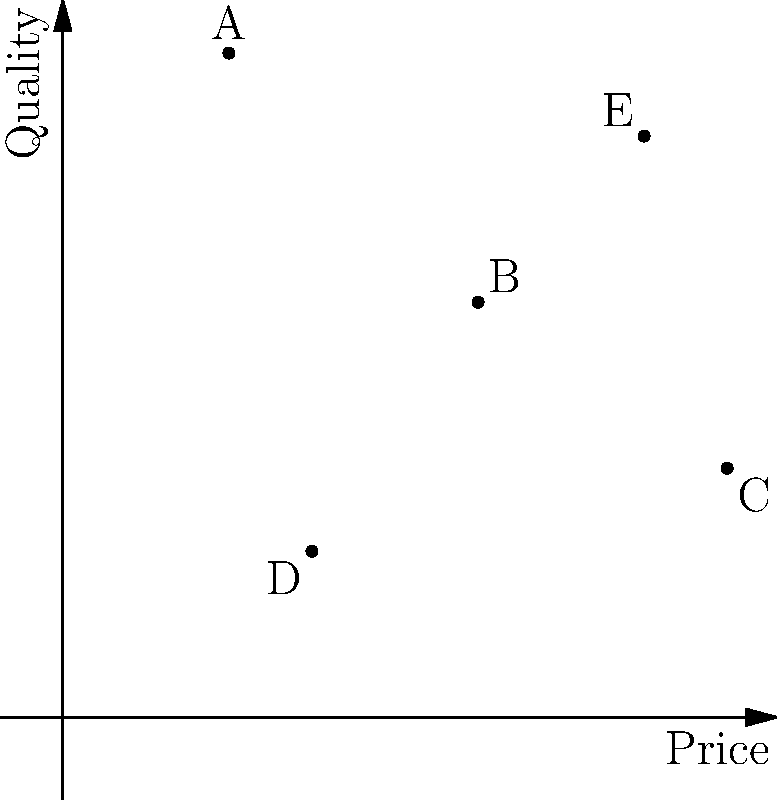Based on the perceptual map showing competitor positioning in terms of price and quality, which competitor appears to have the highest price and lowest quality perception? To answer this question, we need to analyze the positions of competitors on the 2D perceptual map:

1. The x-axis represents price, with values increasing from left to right.
2. The y-axis represents quality, with values increasing from bottom to top.
3. We need to identify the competitor with the highest x-coordinate (price) and lowest y-coordinate (quality).

Examining each competitor:
A: Low price, high quality
B: Medium price, medium quality
C: High price, low quality
D: Low-medium price, low quality
E: High price, high quality

Competitor C has the highest x-coordinate (price) and one of the lowest y-coordinates (quality) among all competitors.
Answer: C 